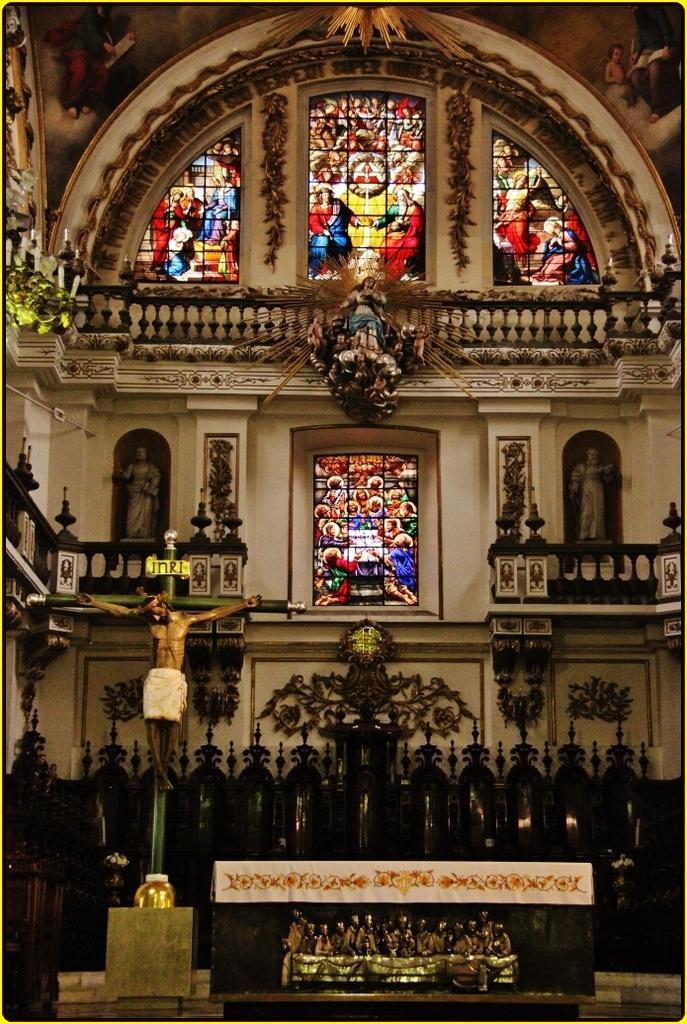In one or two sentences, can you explain what this image depicts? This picture was taken in the church. This is the statue of a person, which is attached to a holy cross symbol. I can see the designs, which are carved on the walls. These are the sculptures. I can see the glass doors with the glass paintings on it. At the bottom of the image, I think this is a table. 